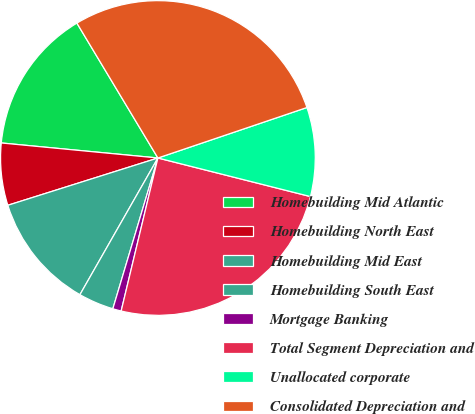Convert chart to OTSL. <chart><loc_0><loc_0><loc_500><loc_500><pie_chart><fcel>Homebuilding Mid Atlantic<fcel>Homebuilding North East<fcel>Homebuilding Mid East<fcel>Homebuilding South East<fcel>Mortgage Banking<fcel>Total Segment Depreciation and<fcel>Unallocated corporate<fcel>Consolidated Depreciation and<nl><fcel>14.87%<fcel>6.38%<fcel>11.89%<fcel>3.63%<fcel>0.87%<fcel>24.81%<fcel>9.14%<fcel>28.41%<nl></chart> 